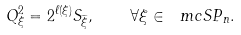Convert formula to latex. <formula><loc_0><loc_0><loc_500><loc_500>Q ^ { 2 } _ { \xi } = 2 ^ { \ell ( \xi ) } S _ { \widetilde { \xi } } , \quad \forall \xi \in \ m c { S P } _ { n } .</formula> 